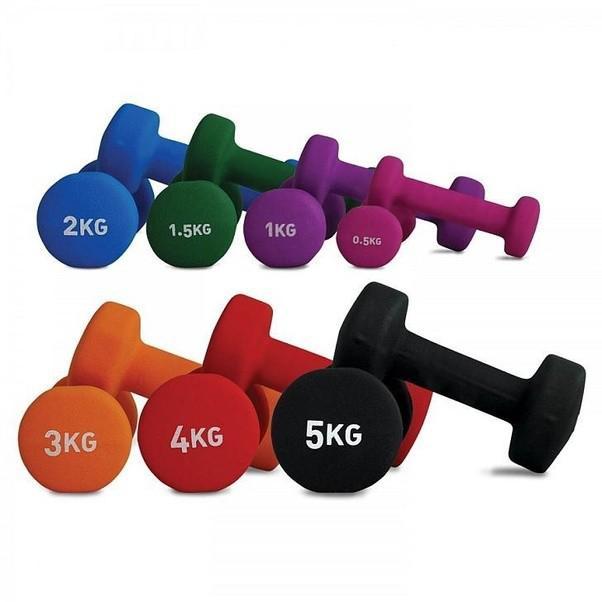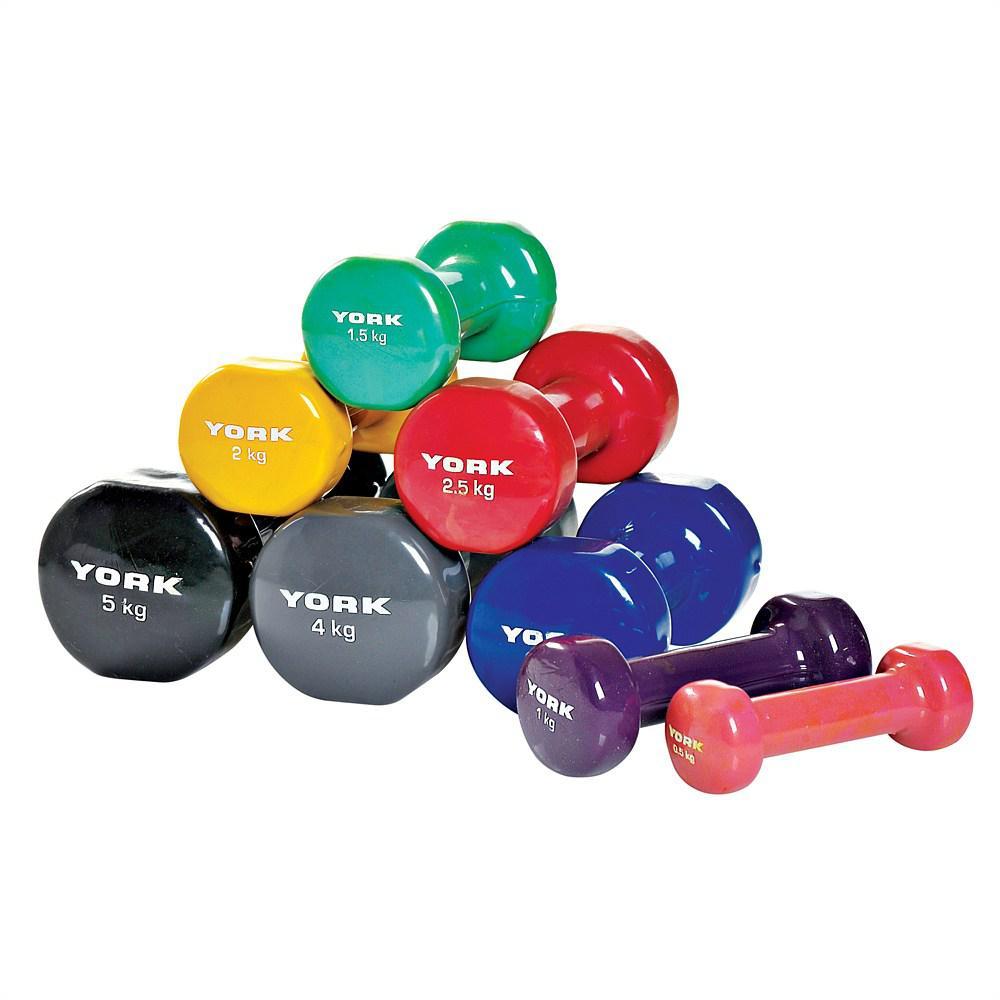The first image is the image on the left, the second image is the image on the right. For the images displayed, is the sentence "In the image to the right, there is only one pair of free weights." factually correct? Answer yes or no. No. 